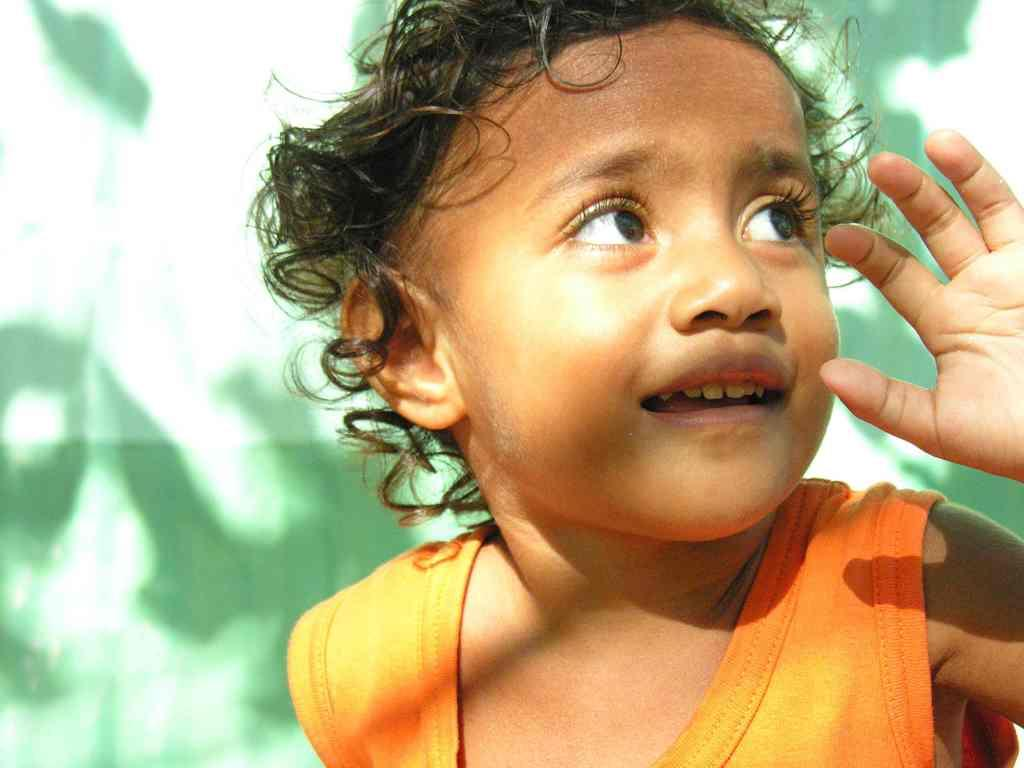What is the main subject of the image? There is a child in the image. What is the child's expression in the image? The child is smiling in the image. What color is the background of the image? The background of the image is green. What type of corn can be seen growing in the background of the image? There is no corn visible in the image; the background is green, but it does not show any specific plants or crops. 